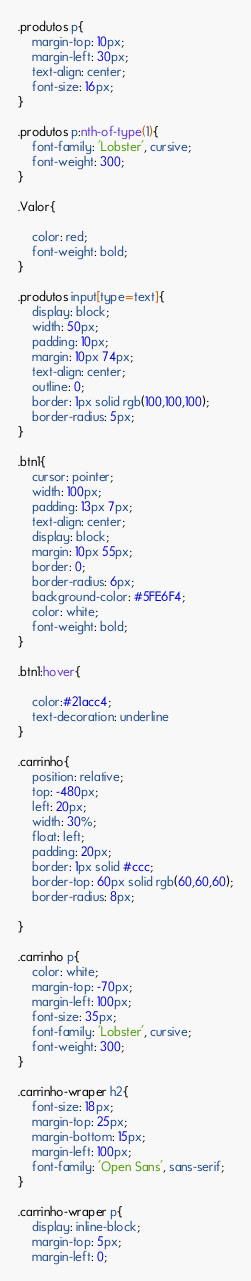Convert code to text. <code><loc_0><loc_0><loc_500><loc_500><_CSS_>.produtos p{
	margin-top: 10px;
	margin-left: 30px;
	text-align: center;
	font-size: 16px;
}

.produtos p:nth-of-type(1){
	font-family: 'Lobster', cursive;
	font-weight: 300;
}

.Valor{

	color: red;
	font-weight: bold;
}

.produtos input[type=text]{
	display: block;
	width: 50px;
	padding: 10px;
	margin: 10px 74px;
	text-align: center;
	outline: 0;
	border: 1px solid rgb(100,100,100);
	border-radius: 5px;
}

.btn1{
	cursor: pointer;
	width: 100px;
	padding: 13px 7px;
	text-align: center;
	display: block;
	margin: 10px 55px;
	border: 0;
	border-radius: 6px;
	background-color: #5FE6F4;
	color: white;
	font-weight: bold;
}

.btn1:hover{

	color:#21acc4;
	text-decoration: underline
}

.carrinho{
	position: relative;
	top: -480px;
	left: 20px;
	width: 30%;
	float: left;
	padding: 20px;
	border: 1px solid #ccc;
	border-top: 60px solid rgb(60,60,60);
	border-radius: 8px;
	
}

.carrinho p{
	color: white;
	margin-top: -70px;
	margin-left: 100px;
	font-size: 35px;
	font-family: 'Lobster', cursive;
	font-weight: 300;
}

.carrinho-wraper h2{
	font-size: 18px;
	margin-top: 25px;
	margin-bottom: 15px;
	margin-left: 100px;
	font-family: 'Open Sans', sans-serif;
}

.carrinho-wraper p{
	display: inline-block;
	margin-top: 5px;
	margin-left: 0;</code> 